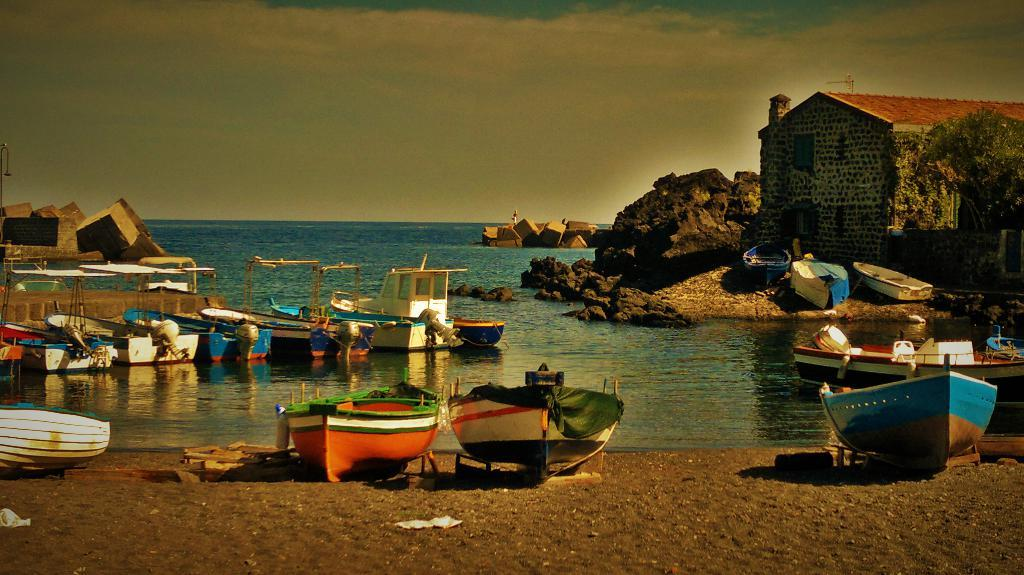What type of vehicles can be seen in the image? There are boats in the image. What type of structure is present in the image? There is a house in the image. What type of natural elements are present in the image? Stones and sand are visible in the image. What type of liquid is present in the image? There is water in the image. What part of the natural environment is visible in the image? The sky is visible in the image. What type of atmospheric phenomena can be seen in the sky? Clouds are present in the sky. What type of treatment is being administered to the swing in the image? There is no swing present in the image. What suggestion is being made by the clouds in the image? The clouds do not make suggestions in the image; they are a natural atmospheric phenomenon. 